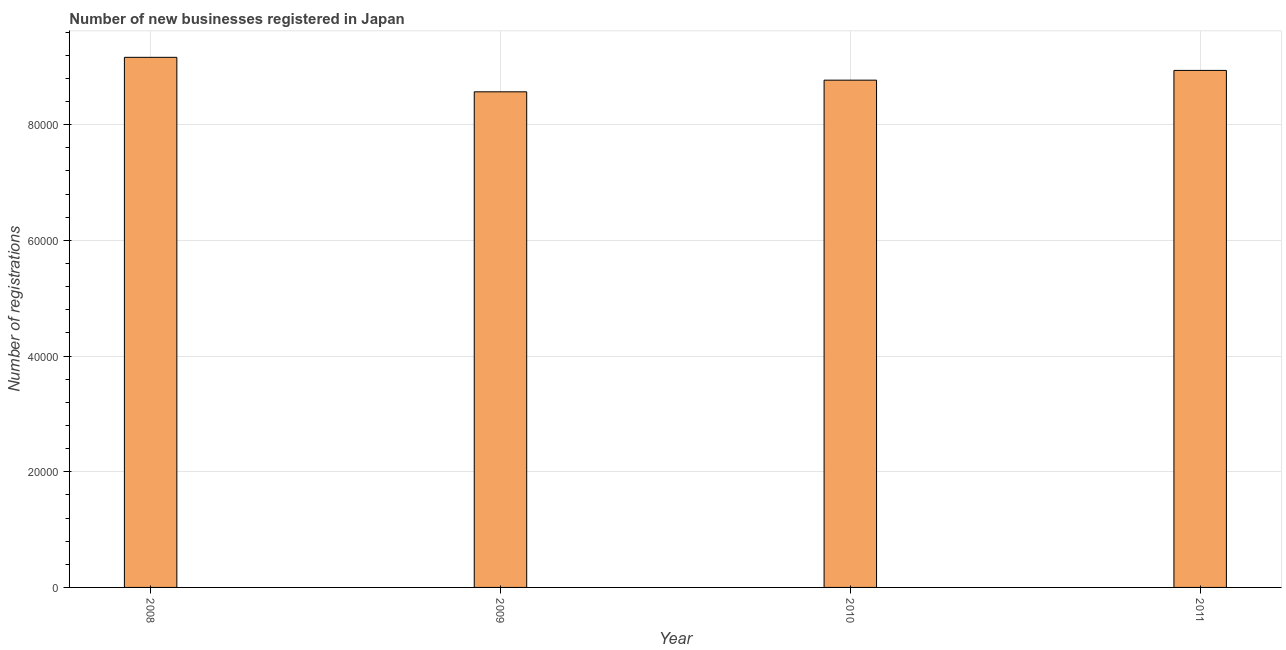Does the graph contain any zero values?
Your answer should be very brief. No. What is the title of the graph?
Give a very brief answer. Number of new businesses registered in Japan. What is the label or title of the Y-axis?
Provide a succinct answer. Number of registrations. What is the number of new business registrations in 2011?
Keep it short and to the point. 8.94e+04. Across all years, what is the maximum number of new business registrations?
Your answer should be compact. 9.16e+04. Across all years, what is the minimum number of new business registrations?
Provide a short and direct response. 8.57e+04. In which year was the number of new business registrations maximum?
Offer a terse response. 2008. What is the sum of the number of new business registrations?
Your answer should be compact. 3.54e+05. What is the difference between the number of new business registrations in 2009 and 2010?
Ensure brevity in your answer.  -2015. What is the average number of new business registrations per year?
Offer a terse response. 8.86e+04. What is the median number of new business registrations?
Offer a terse response. 8.85e+04. In how many years, is the number of new business registrations greater than 56000 ?
Keep it short and to the point. 4. Do a majority of the years between 2009 and 2011 (inclusive) have number of new business registrations greater than 36000 ?
Offer a terse response. Yes. What is the ratio of the number of new business registrations in 2010 to that in 2011?
Your answer should be very brief. 0.98. Is the number of new business registrations in 2009 less than that in 2010?
Make the answer very short. Yes. Is the difference between the number of new business registrations in 2010 and 2011 greater than the difference between any two years?
Keep it short and to the point. No. What is the difference between the highest and the second highest number of new business registrations?
Give a very brief answer. 2262. Is the sum of the number of new business registrations in 2010 and 2011 greater than the maximum number of new business registrations across all years?
Your answer should be very brief. Yes. What is the difference between the highest and the lowest number of new business registrations?
Make the answer very short. 5962. How many bars are there?
Your response must be concise. 4. Are all the bars in the graph horizontal?
Provide a succinct answer. No. What is the difference between two consecutive major ticks on the Y-axis?
Make the answer very short. 2.00e+04. What is the Number of registrations in 2008?
Your answer should be compact. 9.16e+04. What is the Number of registrations in 2009?
Your response must be concise. 8.57e+04. What is the Number of registrations in 2010?
Your response must be concise. 8.77e+04. What is the Number of registrations of 2011?
Keep it short and to the point. 8.94e+04. What is the difference between the Number of registrations in 2008 and 2009?
Make the answer very short. 5962. What is the difference between the Number of registrations in 2008 and 2010?
Keep it short and to the point. 3947. What is the difference between the Number of registrations in 2008 and 2011?
Give a very brief answer. 2262. What is the difference between the Number of registrations in 2009 and 2010?
Provide a succinct answer. -2015. What is the difference between the Number of registrations in 2009 and 2011?
Provide a succinct answer. -3700. What is the difference between the Number of registrations in 2010 and 2011?
Offer a very short reply. -1685. What is the ratio of the Number of registrations in 2008 to that in 2009?
Ensure brevity in your answer.  1.07. What is the ratio of the Number of registrations in 2008 to that in 2010?
Ensure brevity in your answer.  1.04. What is the ratio of the Number of registrations in 2010 to that in 2011?
Your answer should be compact. 0.98. 